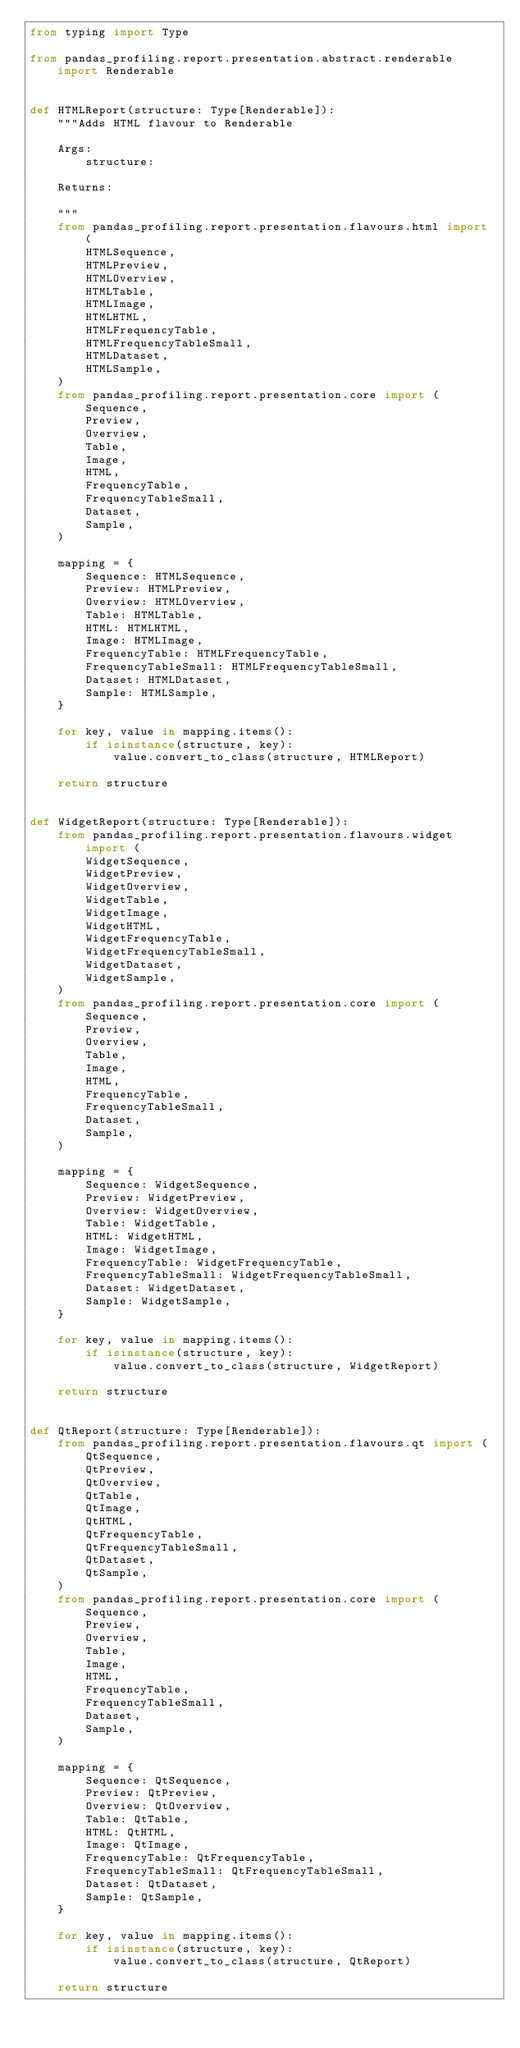Convert code to text. <code><loc_0><loc_0><loc_500><loc_500><_Python_>from typing import Type

from pandas_profiling.report.presentation.abstract.renderable import Renderable


def HTMLReport(structure: Type[Renderable]):
    """Adds HTML flavour to Renderable

    Args:
        structure:

    Returns:

    """
    from pandas_profiling.report.presentation.flavours.html import (
        HTMLSequence,
        HTMLPreview,
        HTMLOverview,
        HTMLTable,
        HTMLImage,
        HTMLHTML,
        HTMLFrequencyTable,
        HTMLFrequencyTableSmall,
        HTMLDataset,
        HTMLSample,
    )
    from pandas_profiling.report.presentation.core import (
        Sequence,
        Preview,
        Overview,
        Table,
        Image,
        HTML,
        FrequencyTable,
        FrequencyTableSmall,
        Dataset,
        Sample,
    )

    mapping = {
        Sequence: HTMLSequence,
        Preview: HTMLPreview,
        Overview: HTMLOverview,
        Table: HTMLTable,
        HTML: HTMLHTML,
        Image: HTMLImage,
        FrequencyTable: HTMLFrequencyTable,
        FrequencyTableSmall: HTMLFrequencyTableSmall,
        Dataset: HTMLDataset,
        Sample: HTMLSample,
    }

    for key, value in mapping.items():
        if isinstance(structure, key):
            value.convert_to_class(structure, HTMLReport)

    return structure


def WidgetReport(structure: Type[Renderable]):
    from pandas_profiling.report.presentation.flavours.widget import (
        WidgetSequence,
        WidgetPreview,
        WidgetOverview,
        WidgetTable,
        WidgetImage,
        WidgetHTML,
        WidgetFrequencyTable,
        WidgetFrequencyTableSmall,
        WidgetDataset,
        WidgetSample,
    )
    from pandas_profiling.report.presentation.core import (
        Sequence,
        Preview,
        Overview,
        Table,
        Image,
        HTML,
        FrequencyTable,
        FrequencyTableSmall,
        Dataset,
        Sample,
    )

    mapping = {
        Sequence: WidgetSequence,
        Preview: WidgetPreview,
        Overview: WidgetOverview,
        Table: WidgetTable,
        HTML: WidgetHTML,
        Image: WidgetImage,
        FrequencyTable: WidgetFrequencyTable,
        FrequencyTableSmall: WidgetFrequencyTableSmall,
        Dataset: WidgetDataset,
        Sample: WidgetSample,
    }

    for key, value in mapping.items():
        if isinstance(structure, key):
            value.convert_to_class(structure, WidgetReport)

    return structure


def QtReport(structure: Type[Renderable]):
    from pandas_profiling.report.presentation.flavours.qt import (
        QtSequence,
        QtPreview,
        QtOverview,
        QtTable,
        QtImage,
        QtHTML,
        QtFrequencyTable,
        QtFrequencyTableSmall,
        QtDataset,
        QtSample,
    )
    from pandas_profiling.report.presentation.core import (
        Sequence,
        Preview,
        Overview,
        Table,
        Image,
        HTML,
        FrequencyTable,
        FrequencyTableSmall,
        Dataset,
        Sample,
    )

    mapping = {
        Sequence: QtSequence,
        Preview: QtPreview,
        Overview: QtOverview,
        Table: QtTable,
        HTML: QtHTML,
        Image: QtImage,
        FrequencyTable: QtFrequencyTable,
        FrequencyTableSmall: QtFrequencyTableSmall,
        Dataset: QtDataset,
        Sample: QtSample,
    }

    for key, value in mapping.items():
        if isinstance(structure, key):
            value.convert_to_class(structure, QtReport)

    return structure
</code> 